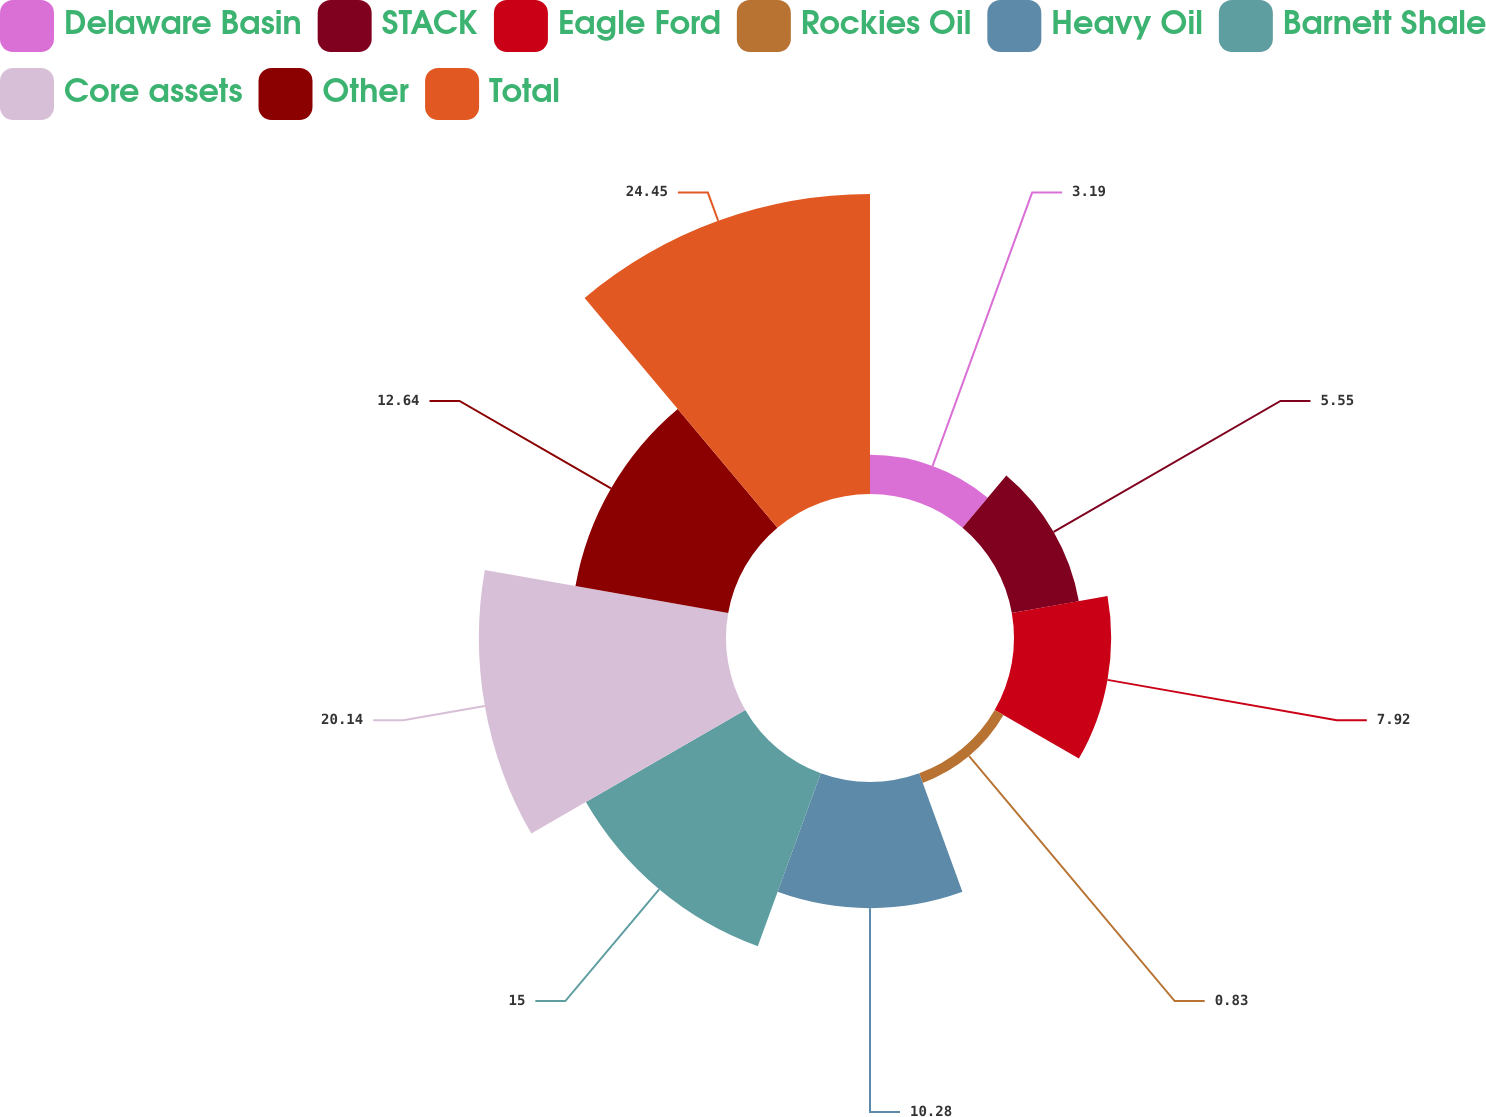<chart> <loc_0><loc_0><loc_500><loc_500><pie_chart><fcel>Delaware Basin<fcel>STACK<fcel>Eagle Ford<fcel>Rockies Oil<fcel>Heavy Oil<fcel>Barnett Shale<fcel>Core assets<fcel>Other<fcel>Total<nl><fcel>3.19%<fcel>5.55%<fcel>7.92%<fcel>0.83%<fcel>10.28%<fcel>15.0%<fcel>20.14%<fcel>12.64%<fcel>24.45%<nl></chart> 